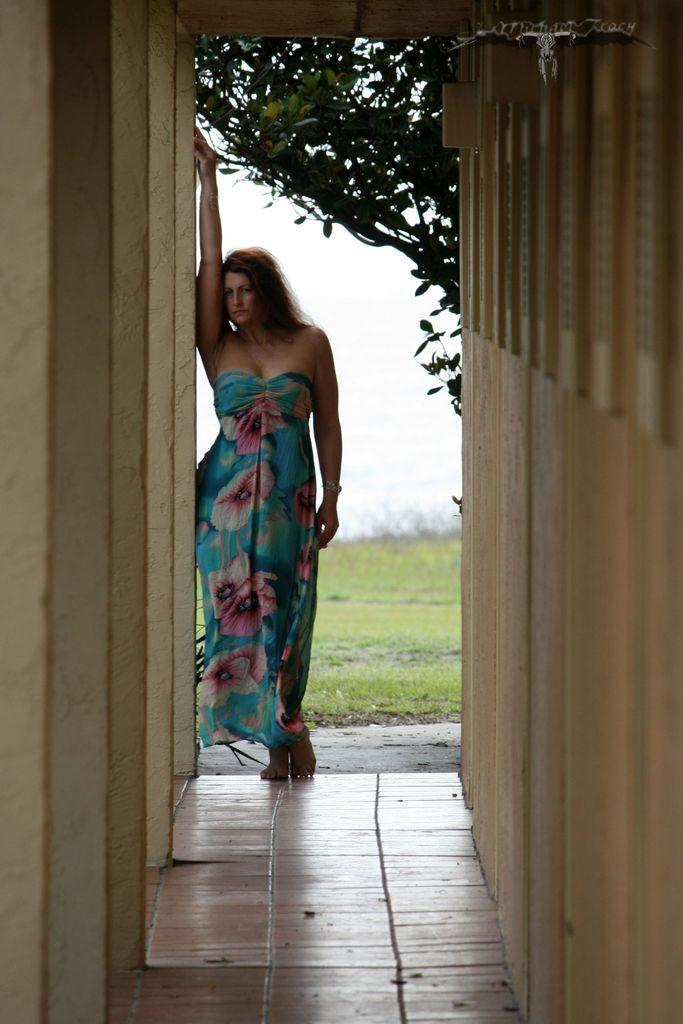What is the main subject in the foreground of the image? There is a woman standing in the foreground of the image. What is the woman standing on? The woman is standing on the floor. What can be seen in the background of the image? There is a wall, grass, trees, and the sky visible in the image. Can you describe the setting of the image? The image appears to be taken outdoors, with grass, trees, and the sky visible in the background. How many fingers does the plant have in the image? There is no plant present in the image, and therefore no fingers to count. What type of bridge can be seen connecting the trees in the image? There is no bridge visible in the image; it features a woman standing on the floor, a wall, grass, trees, and the sky. 